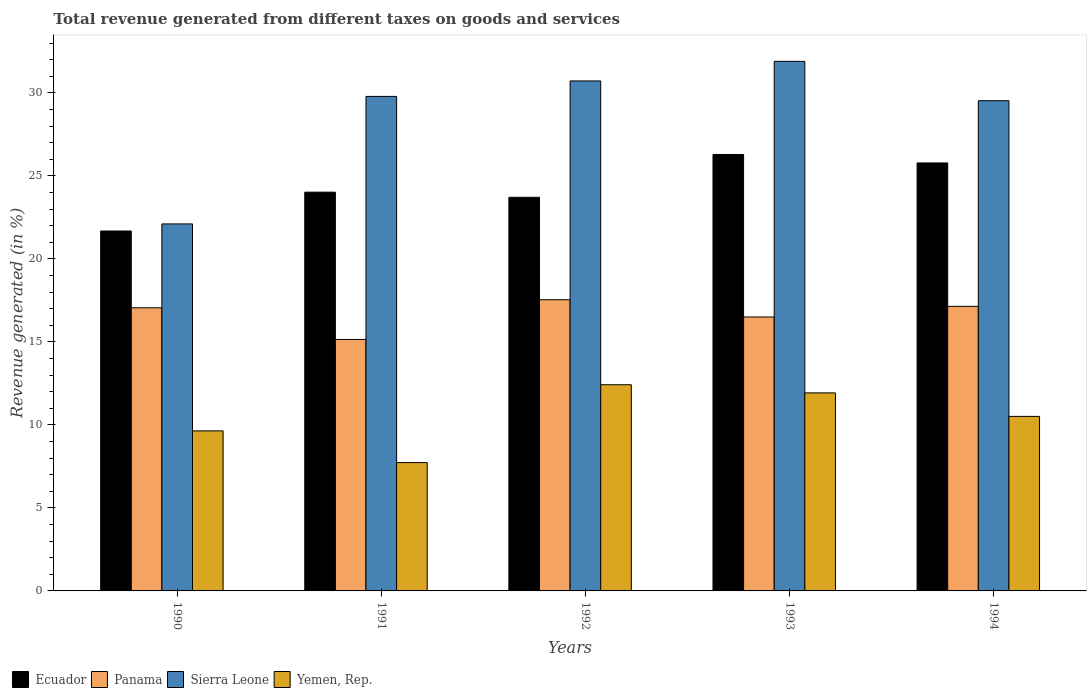How many different coloured bars are there?
Make the answer very short. 4. How many groups of bars are there?
Make the answer very short. 5. Are the number of bars per tick equal to the number of legend labels?
Keep it short and to the point. Yes. In how many cases, is the number of bars for a given year not equal to the number of legend labels?
Offer a terse response. 0. What is the total revenue generated in Panama in 1990?
Your response must be concise. 17.05. Across all years, what is the maximum total revenue generated in Yemen, Rep.?
Your response must be concise. 12.42. Across all years, what is the minimum total revenue generated in Sierra Leone?
Offer a very short reply. 22.1. In which year was the total revenue generated in Ecuador maximum?
Your response must be concise. 1993. In which year was the total revenue generated in Panama minimum?
Offer a very short reply. 1991. What is the total total revenue generated in Ecuador in the graph?
Your response must be concise. 121.47. What is the difference between the total revenue generated in Panama in 1990 and that in 1992?
Provide a short and direct response. -0.48. What is the difference between the total revenue generated in Sierra Leone in 1993 and the total revenue generated in Panama in 1994?
Your answer should be compact. 14.76. What is the average total revenue generated in Ecuador per year?
Offer a terse response. 24.29. In the year 1991, what is the difference between the total revenue generated in Ecuador and total revenue generated in Panama?
Give a very brief answer. 8.87. What is the ratio of the total revenue generated in Sierra Leone in 1991 to that in 1992?
Your response must be concise. 0.97. What is the difference between the highest and the second highest total revenue generated in Ecuador?
Make the answer very short. 0.51. What is the difference between the highest and the lowest total revenue generated in Yemen, Rep.?
Ensure brevity in your answer.  4.69. Is it the case that in every year, the sum of the total revenue generated in Yemen, Rep. and total revenue generated in Sierra Leone is greater than the sum of total revenue generated in Ecuador and total revenue generated in Panama?
Provide a short and direct response. No. What does the 3rd bar from the left in 1992 represents?
Your answer should be compact. Sierra Leone. What does the 1st bar from the right in 1994 represents?
Your answer should be compact. Yemen, Rep. How many bars are there?
Offer a very short reply. 20. Are all the bars in the graph horizontal?
Your answer should be very brief. No. What is the difference between two consecutive major ticks on the Y-axis?
Make the answer very short. 5. Does the graph contain any zero values?
Give a very brief answer. No. Does the graph contain grids?
Your answer should be very brief. No. How are the legend labels stacked?
Ensure brevity in your answer.  Horizontal. What is the title of the graph?
Offer a very short reply. Total revenue generated from different taxes on goods and services. What is the label or title of the Y-axis?
Offer a terse response. Revenue generated (in %). What is the Revenue generated (in %) in Ecuador in 1990?
Make the answer very short. 21.68. What is the Revenue generated (in %) of Panama in 1990?
Make the answer very short. 17.05. What is the Revenue generated (in %) in Sierra Leone in 1990?
Provide a succinct answer. 22.1. What is the Revenue generated (in %) of Yemen, Rep. in 1990?
Your response must be concise. 9.64. What is the Revenue generated (in %) in Ecuador in 1991?
Make the answer very short. 24.02. What is the Revenue generated (in %) of Panama in 1991?
Your response must be concise. 15.15. What is the Revenue generated (in %) in Sierra Leone in 1991?
Your answer should be very brief. 29.78. What is the Revenue generated (in %) in Yemen, Rep. in 1991?
Your answer should be very brief. 7.73. What is the Revenue generated (in %) of Ecuador in 1992?
Your response must be concise. 23.71. What is the Revenue generated (in %) of Panama in 1992?
Your response must be concise. 17.54. What is the Revenue generated (in %) of Sierra Leone in 1992?
Your response must be concise. 30.72. What is the Revenue generated (in %) of Yemen, Rep. in 1992?
Make the answer very short. 12.42. What is the Revenue generated (in %) in Ecuador in 1993?
Keep it short and to the point. 26.29. What is the Revenue generated (in %) in Panama in 1993?
Offer a terse response. 16.5. What is the Revenue generated (in %) in Sierra Leone in 1993?
Keep it short and to the point. 31.89. What is the Revenue generated (in %) of Yemen, Rep. in 1993?
Give a very brief answer. 11.93. What is the Revenue generated (in %) in Ecuador in 1994?
Make the answer very short. 25.78. What is the Revenue generated (in %) of Panama in 1994?
Keep it short and to the point. 17.14. What is the Revenue generated (in %) of Sierra Leone in 1994?
Your response must be concise. 29.52. What is the Revenue generated (in %) of Yemen, Rep. in 1994?
Provide a succinct answer. 10.51. Across all years, what is the maximum Revenue generated (in %) of Ecuador?
Offer a terse response. 26.29. Across all years, what is the maximum Revenue generated (in %) in Panama?
Ensure brevity in your answer.  17.54. Across all years, what is the maximum Revenue generated (in %) of Sierra Leone?
Make the answer very short. 31.89. Across all years, what is the maximum Revenue generated (in %) in Yemen, Rep.?
Offer a terse response. 12.42. Across all years, what is the minimum Revenue generated (in %) in Ecuador?
Your response must be concise. 21.68. Across all years, what is the minimum Revenue generated (in %) in Panama?
Offer a terse response. 15.15. Across all years, what is the minimum Revenue generated (in %) of Sierra Leone?
Give a very brief answer. 22.1. Across all years, what is the minimum Revenue generated (in %) in Yemen, Rep.?
Make the answer very short. 7.73. What is the total Revenue generated (in %) of Ecuador in the graph?
Offer a terse response. 121.47. What is the total Revenue generated (in %) of Panama in the graph?
Make the answer very short. 83.37. What is the total Revenue generated (in %) of Sierra Leone in the graph?
Provide a short and direct response. 144.02. What is the total Revenue generated (in %) in Yemen, Rep. in the graph?
Your response must be concise. 52.22. What is the difference between the Revenue generated (in %) in Ecuador in 1990 and that in 1991?
Give a very brief answer. -2.34. What is the difference between the Revenue generated (in %) of Panama in 1990 and that in 1991?
Your answer should be compact. 1.91. What is the difference between the Revenue generated (in %) in Sierra Leone in 1990 and that in 1991?
Make the answer very short. -7.68. What is the difference between the Revenue generated (in %) in Yemen, Rep. in 1990 and that in 1991?
Offer a very short reply. 1.91. What is the difference between the Revenue generated (in %) of Ecuador in 1990 and that in 1992?
Offer a very short reply. -2.03. What is the difference between the Revenue generated (in %) of Panama in 1990 and that in 1992?
Make the answer very short. -0.48. What is the difference between the Revenue generated (in %) in Sierra Leone in 1990 and that in 1992?
Your answer should be compact. -8.61. What is the difference between the Revenue generated (in %) in Yemen, Rep. in 1990 and that in 1992?
Your response must be concise. -2.78. What is the difference between the Revenue generated (in %) in Ecuador in 1990 and that in 1993?
Offer a very short reply. -4.61. What is the difference between the Revenue generated (in %) in Panama in 1990 and that in 1993?
Your answer should be compact. 0.55. What is the difference between the Revenue generated (in %) in Sierra Leone in 1990 and that in 1993?
Your answer should be compact. -9.79. What is the difference between the Revenue generated (in %) in Yemen, Rep. in 1990 and that in 1993?
Your response must be concise. -2.29. What is the difference between the Revenue generated (in %) in Ecuador in 1990 and that in 1994?
Your answer should be very brief. -4.1. What is the difference between the Revenue generated (in %) in Panama in 1990 and that in 1994?
Your response must be concise. -0.09. What is the difference between the Revenue generated (in %) of Sierra Leone in 1990 and that in 1994?
Your response must be concise. -7.42. What is the difference between the Revenue generated (in %) in Yemen, Rep. in 1990 and that in 1994?
Your answer should be compact. -0.87. What is the difference between the Revenue generated (in %) in Ecuador in 1991 and that in 1992?
Give a very brief answer. 0.31. What is the difference between the Revenue generated (in %) of Panama in 1991 and that in 1992?
Keep it short and to the point. -2.39. What is the difference between the Revenue generated (in %) in Sierra Leone in 1991 and that in 1992?
Provide a succinct answer. -0.93. What is the difference between the Revenue generated (in %) of Yemen, Rep. in 1991 and that in 1992?
Provide a succinct answer. -4.69. What is the difference between the Revenue generated (in %) of Ecuador in 1991 and that in 1993?
Offer a terse response. -2.27. What is the difference between the Revenue generated (in %) in Panama in 1991 and that in 1993?
Your response must be concise. -1.35. What is the difference between the Revenue generated (in %) in Sierra Leone in 1991 and that in 1993?
Keep it short and to the point. -2.11. What is the difference between the Revenue generated (in %) in Yemen, Rep. in 1991 and that in 1993?
Make the answer very short. -4.2. What is the difference between the Revenue generated (in %) of Ecuador in 1991 and that in 1994?
Your answer should be very brief. -1.76. What is the difference between the Revenue generated (in %) of Panama in 1991 and that in 1994?
Your answer should be very brief. -1.99. What is the difference between the Revenue generated (in %) of Sierra Leone in 1991 and that in 1994?
Offer a terse response. 0.26. What is the difference between the Revenue generated (in %) of Yemen, Rep. in 1991 and that in 1994?
Offer a terse response. -2.78. What is the difference between the Revenue generated (in %) of Ecuador in 1992 and that in 1993?
Make the answer very short. -2.58. What is the difference between the Revenue generated (in %) in Panama in 1992 and that in 1993?
Give a very brief answer. 1.04. What is the difference between the Revenue generated (in %) in Sierra Leone in 1992 and that in 1993?
Give a very brief answer. -1.18. What is the difference between the Revenue generated (in %) of Yemen, Rep. in 1992 and that in 1993?
Provide a succinct answer. 0.49. What is the difference between the Revenue generated (in %) of Ecuador in 1992 and that in 1994?
Your answer should be very brief. -2.07. What is the difference between the Revenue generated (in %) in Panama in 1992 and that in 1994?
Ensure brevity in your answer.  0.4. What is the difference between the Revenue generated (in %) in Sierra Leone in 1992 and that in 1994?
Provide a short and direct response. 1.19. What is the difference between the Revenue generated (in %) of Yemen, Rep. in 1992 and that in 1994?
Your response must be concise. 1.91. What is the difference between the Revenue generated (in %) of Ecuador in 1993 and that in 1994?
Ensure brevity in your answer.  0.51. What is the difference between the Revenue generated (in %) in Panama in 1993 and that in 1994?
Your response must be concise. -0.64. What is the difference between the Revenue generated (in %) of Sierra Leone in 1993 and that in 1994?
Your answer should be very brief. 2.37. What is the difference between the Revenue generated (in %) of Yemen, Rep. in 1993 and that in 1994?
Provide a succinct answer. 1.42. What is the difference between the Revenue generated (in %) in Ecuador in 1990 and the Revenue generated (in %) in Panama in 1991?
Provide a short and direct response. 6.53. What is the difference between the Revenue generated (in %) of Ecuador in 1990 and the Revenue generated (in %) of Sierra Leone in 1991?
Offer a terse response. -8.11. What is the difference between the Revenue generated (in %) in Ecuador in 1990 and the Revenue generated (in %) in Yemen, Rep. in 1991?
Your response must be concise. 13.95. What is the difference between the Revenue generated (in %) in Panama in 1990 and the Revenue generated (in %) in Sierra Leone in 1991?
Offer a terse response. -12.73. What is the difference between the Revenue generated (in %) in Panama in 1990 and the Revenue generated (in %) in Yemen, Rep. in 1991?
Ensure brevity in your answer.  9.32. What is the difference between the Revenue generated (in %) of Sierra Leone in 1990 and the Revenue generated (in %) of Yemen, Rep. in 1991?
Offer a terse response. 14.37. What is the difference between the Revenue generated (in %) of Ecuador in 1990 and the Revenue generated (in %) of Panama in 1992?
Keep it short and to the point. 4.14. What is the difference between the Revenue generated (in %) of Ecuador in 1990 and the Revenue generated (in %) of Sierra Leone in 1992?
Your answer should be compact. -9.04. What is the difference between the Revenue generated (in %) in Ecuador in 1990 and the Revenue generated (in %) in Yemen, Rep. in 1992?
Offer a very short reply. 9.26. What is the difference between the Revenue generated (in %) of Panama in 1990 and the Revenue generated (in %) of Sierra Leone in 1992?
Your answer should be compact. -13.66. What is the difference between the Revenue generated (in %) of Panama in 1990 and the Revenue generated (in %) of Yemen, Rep. in 1992?
Provide a short and direct response. 4.63. What is the difference between the Revenue generated (in %) of Sierra Leone in 1990 and the Revenue generated (in %) of Yemen, Rep. in 1992?
Your answer should be compact. 9.69. What is the difference between the Revenue generated (in %) of Ecuador in 1990 and the Revenue generated (in %) of Panama in 1993?
Your response must be concise. 5.18. What is the difference between the Revenue generated (in %) of Ecuador in 1990 and the Revenue generated (in %) of Sierra Leone in 1993?
Offer a very short reply. -10.22. What is the difference between the Revenue generated (in %) in Ecuador in 1990 and the Revenue generated (in %) in Yemen, Rep. in 1993?
Your answer should be compact. 9.75. What is the difference between the Revenue generated (in %) in Panama in 1990 and the Revenue generated (in %) in Sierra Leone in 1993?
Ensure brevity in your answer.  -14.84. What is the difference between the Revenue generated (in %) in Panama in 1990 and the Revenue generated (in %) in Yemen, Rep. in 1993?
Ensure brevity in your answer.  5.13. What is the difference between the Revenue generated (in %) in Sierra Leone in 1990 and the Revenue generated (in %) in Yemen, Rep. in 1993?
Your answer should be compact. 10.18. What is the difference between the Revenue generated (in %) of Ecuador in 1990 and the Revenue generated (in %) of Panama in 1994?
Ensure brevity in your answer.  4.54. What is the difference between the Revenue generated (in %) in Ecuador in 1990 and the Revenue generated (in %) in Sierra Leone in 1994?
Offer a very short reply. -7.85. What is the difference between the Revenue generated (in %) of Ecuador in 1990 and the Revenue generated (in %) of Yemen, Rep. in 1994?
Provide a succinct answer. 11.17. What is the difference between the Revenue generated (in %) in Panama in 1990 and the Revenue generated (in %) in Sierra Leone in 1994?
Ensure brevity in your answer.  -12.47. What is the difference between the Revenue generated (in %) of Panama in 1990 and the Revenue generated (in %) of Yemen, Rep. in 1994?
Offer a terse response. 6.54. What is the difference between the Revenue generated (in %) in Sierra Leone in 1990 and the Revenue generated (in %) in Yemen, Rep. in 1994?
Keep it short and to the point. 11.59. What is the difference between the Revenue generated (in %) in Ecuador in 1991 and the Revenue generated (in %) in Panama in 1992?
Offer a terse response. 6.48. What is the difference between the Revenue generated (in %) in Ecuador in 1991 and the Revenue generated (in %) in Sierra Leone in 1992?
Your answer should be compact. -6.7. What is the difference between the Revenue generated (in %) of Ecuador in 1991 and the Revenue generated (in %) of Yemen, Rep. in 1992?
Make the answer very short. 11.6. What is the difference between the Revenue generated (in %) in Panama in 1991 and the Revenue generated (in %) in Sierra Leone in 1992?
Provide a succinct answer. -15.57. What is the difference between the Revenue generated (in %) in Panama in 1991 and the Revenue generated (in %) in Yemen, Rep. in 1992?
Keep it short and to the point. 2.73. What is the difference between the Revenue generated (in %) in Sierra Leone in 1991 and the Revenue generated (in %) in Yemen, Rep. in 1992?
Make the answer very short. 17.37. What is the difference between the Revenue generated (in %) of Ecuador in 1991 and the Revenue generated (in %) of Panama in 1993?
Your answer should be very brief. 7.52. What is the difference between the Revenue generated (in %) in Ecuador in 1991 and the Revenue generated (in %) in Sierra Leone in 1993?
Your answer should be compact. -7.88. What is the difference between the Revenue generated (in %) of Ecuador in 1991 and the Revenue generated (in %) of Yemen, Rep. in 1993?
Provide a short and direct response. 12.09. What is the difference between the Revenue generated (in %) of Panama in 1991 and the Revenue generated (in %) of Sierra Leone in 1993?
Keep it short and to the point. -16.75. What is the difference between the Revenue generated (in %) of Panama in 1991 and the Revenue generated (in %) of Yemen, Rep. in 1993?
Offer a very short reply. 3.22. What is the difference between the Revenue generated (in %) in Sierra Leone in 1991 and the Revenue generated (in %) in Yemen, Rep. in 1993?
Ensure brevity in your answer.  17.86. What is the difference between the Revenue generated (in %) of Ecuador in 1991 and the Revenue generated (in %) of Panama in 1994?
Ensure brevity in your answer.  6.88. What is the difference between the Revenue generated (in %) of Ecuador in 1991 and the Revenue generated (in %) of Sierra Leone in 1994?
Give a very brief answer. -5.51. What is the difference between the Revenue generated (in %) of Ecuador in 1991 and the Revenue generated (in %) of Yemen, Rep. in 1994?
Give a very brief answer. 13.51. What is the difference between the Revenue generated (in %) in Panama in 1991 and the Revenue generated (in %) in Sierra Leone in 1994?
Your answer should be very brief. -14.38. What is the difference between the Revenue generated (in %) in Panama in 1991 and the Revenue generated (in %) in Yemen, Rep. in 1994?
Give a very brief answer. 4.63. What is the difference between the Revenue generated (in %) of Sierra Leone in 1991 and the Revenue generated (in %) of Yemen, Rep. in 1994?
Offer a terse response. 19.27. What is the difference between the Revenue generated (in %) of Ecuador in 1992 and the Revenue generated (in %) of Panama in 1993?
Provide a short and direct response. 7.21. What is the difference between the Revenue generated (in %) of Ecuador in 1992 and the Revenue generated (in %) of Sierra Leone in 1993?
Your answer should be very brief. -8.19. What is the difference between the Revenue generated (in %) of Ecuador in 1992 and the Revenue generated (in %) of Yemen, Rep. in 1993?
Make the answer very short. 11.78. What is the difference between the Revenue generated (in %) in Panama in 1992 and the Revenue generated (in %) in Sierra Leone in 1993?
Make the answer very short. -14.36. What is the difference between the Revenue generated (in %) in Panama in 1992 and the Revenue generated (in %) in Yemen, Rep. in 1993?
Make the answer very short. 5.61. What is the difference between the Revenue generated (in %) in Sierra Leone in 1992 and the Revenue generated (in %) in Yemen, Rep. in 1993?
Your answer should be very brief. 18.79. What is the difference between the Revenue generated (in %) of Ecuador in 1992 and the Revenue generated (in %) of Panama in 1994?
Offer a terse response. 6.57. What is the difference between the Revenue generated (in %) of Ecuador in 1992 and the Revenue generated (in %) of Sierra Leone in 1994?
Keep it short and to the point. -5.82. What is the difference between the Revenue generated (in %) of Ecuador in 1992 and the Revenue generated (in %) of Yemen, Rep. in 1994?
Your answer should be compact. 13.2. What is the difference between the Revenue generated (in %) of Panama in 1992 and the Revenue generated (in %) of Sierra Leone in 1994?
Provide a succinct answer. -11.99. What is the difference between the Revenue generated (in %) in Panama in 1992 and the Revenue generated (in %) in Yemen, Rep. in 1994?
Your answer should be very brief. 7.03. What is the difference between the Revenue generated (in %) of Sierra Leone in 1992 and the Revenue generated (in %) of Yemen, Rep. in 1994?
Keep it short and to the point. 20.2. What is the difference between the Revenue generated (in %) in Ecuador in 1993 and the Revenue generated (in %) in Panama in 1994?
Your answer should be very brief. 9.15. What is the difference between the Revenue generated (in %) of Ecuador in 1993 and the Revenue generated (in %) of Sierra Leone in 1994?
Offer a terse response. -3.24. What is the difference between the Revenue generated (in %) of Ecuador in 1993 and the Revenue generated (in %) of Yemen, Rep. in 1994?
Make the answer very short. 15.78. What is the difference between the Revenue generated (in %) in Panama in 1993 and the Revenue generated (in %) in Sierra Leone in 1994?
Provide a succinct answer. -13.03. What is the difference between the Revenue generated (in %) in Panama in 1993 and the Revenue generated (in %) in Yemen, Rep. in 1994?
Your answer should be very brief. 5.99. What is the difference between the Revenue generated (in %) in Sierra Leone in 1993 and the Revenue generated (in %) in Yemen, Rep. in 1994?
Ensure brevity in your answer.  21.38. What is the average Revenue generated (in %) in Ecuador per year?
Your response must be concise. 24.29. What is the average Revenue generated (in %) of Panama per year?
Give a very brief answer. 16.67. What is the average Revenue generated (in %) in Sierra Leone per year?
Your response must be concise. 28.8. What is the average Revenue generated (in %) in Yemen, Rep. per year?
Provide a succinct answer. 10.44. In the year 1990, what is the difference between the Revenue generated (in %) in Ecuador and Revenue generated (in %) in Panama?
Provide a short and direct response. 4.63. In the year 1990, what is the difference between the Revenue generated (in %) in Ecuador and Revenue generated (in %) in Sierra Leone?
Your response must be concise. -0.43. In the year 1990, what is the difference between the Revenue generated (in %) in Ecuador and Revenue generated (in %) in Yemen, Rep.?
Make the answer very short. 12.04. In the year 1990, what is the difference between the Revenue generated (in %) in Panama and Revenue generated (in %) in Sierra Leone?
Ensure brevity in your answer.  -5.05. In the year 1990, what is the difference between the Revenue generated (in %) of Panama and Revenue generated (in %) of Yemen, Rep.?
Keep it short and to the point. 7.41. In the year 1990, what is the difference between the Revenue generated (in %) of Sierra Leone and Revenue generated (in %) of Yemen, Rep.?
Make the answer very short. 12.46. In the year 1991, what is the difference between the Revenue generated (in %) of Ecuador and Revenue generated (in %) of Panama?
Keep it short and to the point. 8.87. In the year 1991, what is the difference between the Revenue generated (in %) of Ecuador and Revenue generated (in %) of Sierra Leone?
Your answer should be very brief. -5.77. In the year 1991, what is the difference between the Revenue generated (in %) in Ecuador and Revenue generated (in %) in Yemen, Rep.?
Your response must be concise. 16.29. In the year 1991, what is the difference between the Revenue generated (in %) in Panama and Revenue generated (in %) in Sierra Leone?
Offer a very short reply. -14.64. In the year 1991, what is the difference between the Revenue generated (in %) in Panama and Revenue generated (in %) in Yemen, Rep.?
Your answer should be very brief. 7.42. In the year 1991, what is the difference between the Revenue generated (in %) of Sierra Leone and Revenue generated (in %) of Yemen, Rep.?
Make the answer very short. 22.05. In the year 1992, what is the difference between the Revenue generated (in %) of Ecuador and Revenue generated (in %) of Panama?
Your answer should be very brief. 6.17. In the year 1992, what is the difference between the Revenue generated (in %) of Ecuador and Revenue generated (in %) of Sierra Leone?
Give a very brief answer. -7.01. In the year 1992, what is the difference between the Revenue generated (in %) in Ecuador and Revenue generated (in %) in Yemen, Rep.?
Offer a terse response. 11.29. In the year 1992, what is the difference between the Revenue generated (in %) in Panama and Revenue generated (in %) in Sierra Leone?
Your answer should be very brief. -13.18. In the year 1992, what is the difference between the Revenue generated (in %) of Panama and Revenue generated (in %) of Yemen, Rep.?
Keep it short and to the point. 5.12. In the year 1992, what is the difference between the Revenue generated (in %) of Sierra Leone and Revenue generated (in %) of Yemen, Rep.?
Provide a short and direct response. 18.3. In the year 1993, what is the difference between the Revenue generated (in %) in Ecuador and Revenue generated (in %) in Panama?
Keep it short and to the point. 9.79. In the year 1993, what is the difference between the Revenue generated (in %) in Ecuador and Revenue generated (in %) in Sierra Leone?
Your answer should be compact. -5.61. In the year 1993, what is the difference between the Revenue generated (in %) in Ecuador and Revenue generated (in %) in Yemen, Rep.?
Provide a succinct answer. 14.36. In the year 1993, what is the difference between the Revenue generated (in %) in Panama and Revenue generated (in %) in Sierra Leone?
Ensure brevity in your answer.  -15.4. In the year 1993, what is the difference between the Revenue generated (in %) in Panama and Revenue generated (in %) in Yemen, Rep.?
Your answer should be compact. 4.57. In the year 1993, what is the difference between the Revenue generated (in %) of Sierra Leone and Revenue generated (in %) of Yemen, Rep.?
Your answer should be very brief. 19.97. In the year 1994, what is the difference between the Revenue generated (in %) in Ecuador and Revenue generated (in %) in Panama?
Your answer should be compact. 8.64. In the year 1994, what is the difference between the Revenue generated (in %) in Ecuador and Revenue generated (in %) in Sierra Leone?
Offer a very short reply. -3.75. In the year 1994, what is the difference between the Revenue generated (in %) of Ecuador and Revenue generated (in %) of Yemen, Rep.?
Your answer should be very brief. 15.27. In the year 1994, what is the difference between the Revenue generated (in %) in Panama and Revenue generated (in %) in Sierra Leone?
Your response must be concise. -12.39. In the year 1994, what is the difference between the Revenue generated (in %) in Panama and Revenue generated (in %) in Yemen, Rep.?
Offer a very short reply. 6.63. In the year 1994, what is the difference between the Revenue generated (in %) of Sierra Leone and Revenue generated (in %) of Yemen, Rep.?
Provide a succinct answer. 19.01. What is the ratio of the Revenue generated (in %) in Ecuador in 1990 to that in 1991?
Keep it short and to the point. 0.9. What is the ratio of the Revenue generated (in %) in Panama in 1990 to that in 1991?
Make the answer very short. 1.13. What is the ratio of the Revenue generated (in %) of Sierra Leone in 1990 to that in 1991?
Offer a very short reply. 0.74. What is the ratio of the Revenue generated (in %) in Yemen, Rep. in 1990 to that in 1991?
Your answer should be compact. 1.25. What is the ratio of the Revenue generated (in %) in Ecuador in 1990 to that in 1992?
Keep it short and to the point. 0.91. What is the ratio of the Revenue generated (in %) in Panama in 1990 to that in 1992?
Offer a very short reply. 0.97. What is the ratio of the Revenue generated (in %) of Sierra Leone in 1990 to that in 1992?
Ensure brevity in your answer.  0.72. What is the ratio of the Revenue generated (in %) in Yemen, Rep. in 1990 to that in 1992?
Your answer should be compact. 0.78. What is the ratio of the Revenue generated (in %) of Ecuador in 1990 to that in 1993?
Offer a terse response. 0.82. What is the ratio of the Revenue generated (in %) in Panama in 1990 to that in 1993?
Provide a succinct answer. 1.03. What is the ratio of the Revenue generated (in %) of Sierra Leone in 1990 to that in 1993?
Your response must be concise. 0.69. What is the ratio of the Revenue generated (in %) in Yemen, Rep. in 1990 to that in 1993?
Offer a very short reply. 0.81. What is the ratio of the Revenue generated (in %) of Ecuador in 1990 to that in 1994?
Ensure brevity in your answer.  0.84. What is the ratio of the Revenue generated (in %) of Sierra Leone in 1990 to that in 1994?
Keep it short and to the point. 0.75. What is the ratio of the Revenue generated (in %) in Yemen, Rep. in 1990 to that in 1994?
Offer a very short reply. 0.92. What is the ratio of the Revenue generated (in %) in Panama in 1991 to that in 1992?
Offer a very short reply. 0.86. What is the ratio of the Revenue generated (in %) of Sierra Leone in 1991 to that in 1992?
Provide a succinct answer. 0.97. What is the ratio of the Revenue generated (in %) of Yemen, Rep. in 1991 to that in 1992?
Your response must be concise. 0.62. What is the ratio of the Revenue generated (in %) in Ecuador in 1991 to that in 1993?
Offer a very short reply. 0.91. What is the ratio of the Revenue generated (in %) in Panama in 1991 to that in 1993?
Provide a succinct answer. 0.92. What is the ratio of the Revenue generated (in %) in Sierra Leone in 1991 to that in 1993?
Give a very brief answer. 0.93. What is the ratio of the Revenue generated (in %) of Yemen, Rep. in 1991 to that in 1993?
Your answer should be compact. 0.65. What is the ratio of the Revenue generated (in %) of Ecuador in 1991 to that in 1994?
Give a very brief answer. 0.93. What is the ratio of the Revenue generated (in %) in Panama in 1991 to that in 1994?
Your answer should be compact. 0.88. What is the ratio of the Revenue generated (in %) in Sierra Leone in 1991 to that in 1994?
Your answer should be compact. 1.01. What is the ratio of the Revenue generated (in %) in Yemen, Rep. in 1991 to that in 1994?
Your response must be concise. 0.74. What is the ratio of the Revenue generated (in %) of Ecuador in 1992 to that in 1993?
Make the answer very short. 0.9. What is the ratio of the Revenue generated (in %) in Panama in 1992 to that in 1993?
Offer a very short reply. 1.06. What is the ratio of the Revenue generated (in %) of Yemen, Rep. in 1992 to that in 1993?
Provide a short and direct response. 1.04. What is the ratio of the Revenue generated (in %) of Ecuador in 1992 to that in 1994?
Provide a succinct answer. 0.92. What is the ratio of the Revenue generated (in %) in Panama in 1992 to that in 1994?
Offer a very short reply. 1.02. What is the ratio of the Revenue generated (in %) of Sierra Leone in 1992 to that in 1994?
Your response must be concise. 1.04. What is the ratio of the Revenue generated (in %) in Yemen, Rep. in 1992 to that in 1994?
Offer a terse response. 1.18. What is the ratio of the Revenue generated (in %) of Ecuador in 1993 to that in 1994?
Keep it short and to the point. 1.02. What is the ratio of the Revenue generated (in %) of Panama in 1993 to that in 1994?
Provide a short and direct response. 0.96. What is the ratio of the Revenue generated (in %) of Sierra Leone in 1993 to that in 1994?
Offer a very short reply. 1.08. What is the ratio of the Revenue generated (in %) in Yemen, Rep. in 1993 to that in 1994?
Offer a terse response. 1.13. What is the difference between the highest and the second highest Revenue generated (in %) of Ecuador?
Your answer should be very brief. 0.51. What is the difference between the highest and the second highest Revenue generated (in %) in Panama?
Make the answer very short. 0.4. What is the difference between the highest and the second highest Revenue generated (in %) in Sierra Leone?
Provide a short and direct response. 1.18. What is the difference between the highest and the second highest Revenue generated (in %) of Yemen, Rep.?
Your answer should be compact. 0.49. What is the difference between the highest and the lowest Revenue generated (in %) in Ecuador?
Your answer should be very brief. 4.61. What is the difference between the highest and the lowest Revenue generated (in %) in Panama?
Offer a very short reply. 2.39. What is the difference between the highest and the lowest Revenue generated (in %) in Sierra Leone?
Offer a terse response. 9.79. What is the difference between the highest and the lowest Revenue generated (in %) in Yemen, Rep.?
Provide a succinct answer. 4.69. 